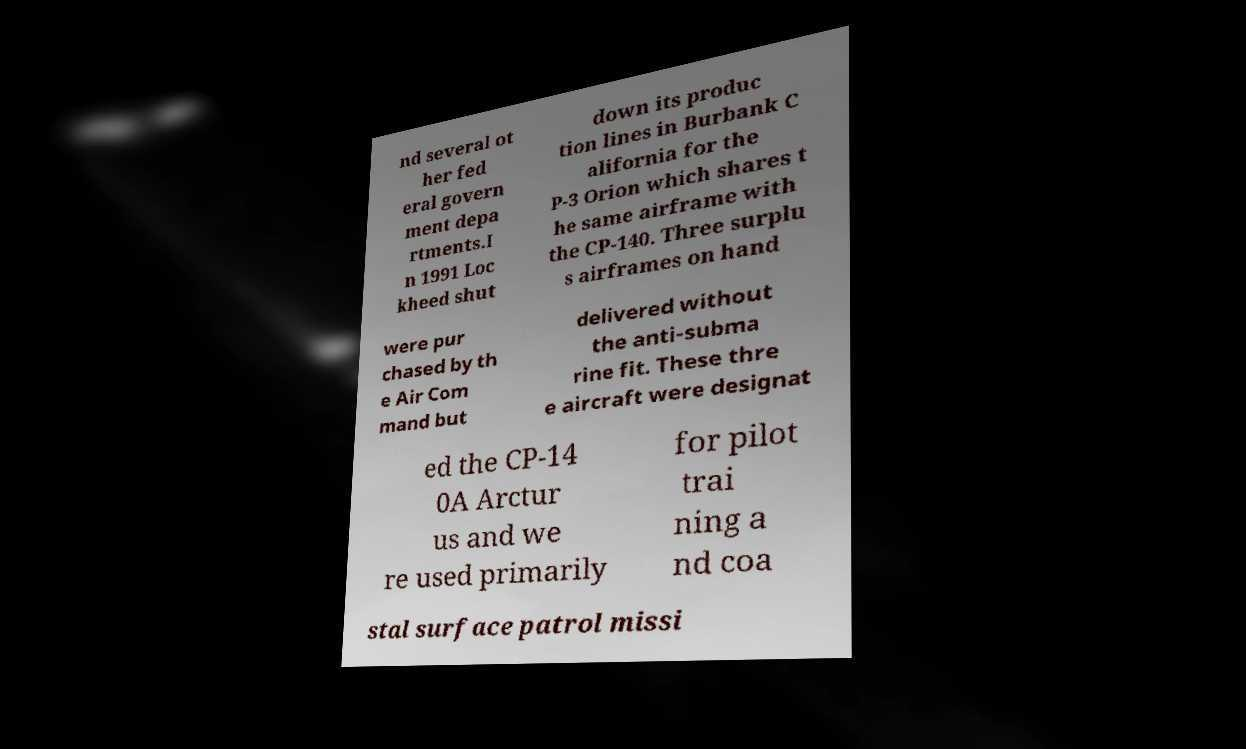Could you assist in decoding the text presented in this image and type it out clearly? nd several ot her fed eral govern ment depa rtments.I n 1991 Loc kheed shut down its produc tion lines in Burbank C alifornia for the P-3 Orion which shares t he same airframe with the CP-140. Three surplu s airframes on hand were pur chased by th e Air Com mand but delivered without the anti-subma rine fit. These thre e aircraft were designat ed the CP-14 0A Arctur us and we re used primarily for pilot trai ning a nd coa stal surface patrol missi 